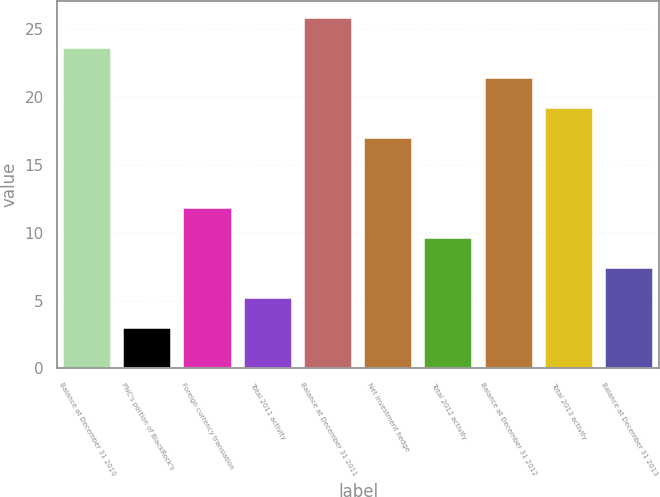<chart> <loc_0><loc_0><loc_500><loc_500><bar_chart><fcel>Balance at December 31 2010<fcel>PNC's portion of BlackRock's<fcel>Foreign currency translation<fcel>Total 2011 activity<fcel>Balance at December 31 2011<fcel>Net investment hedge<fcel>Total 2012 activity<fcel>Balance at December 31 2012<fcel>Total 2013 activity<fcel>Balance at December 31 2013<nl><fcel>23.6<fcel>3<fcel>11.8<fcel>5.2<fcel>25.8<fcel>17<fcel>9.6<fcel>21.4<fcel>19.2<fcel>7.4<nl></chart> 